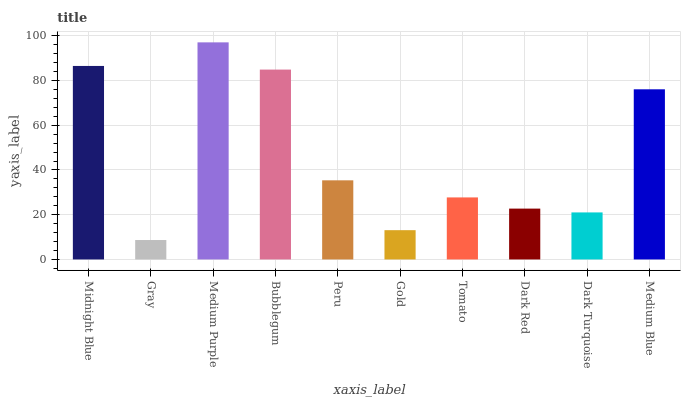Is Gray the minimum?
Answer yes or no. Yes. Is Medium Purple the maximum?
Answer yes or no. Yes. Is Medium Purple the minimum?
Answer yes or no. No. Is Gray the maximum?
Answer yes or no. No. Is Medium Purple greater than Gray?
Answer yes or no. Yes. Is Gray less than Medium Purple?
Answer yes or no. Yes. Is Gray greater than Medium Purple?
Answer yes or no. No. Is Medium Purple less than Gray?
Answer yes or no. No. Is Peru the high median?
Answer yes or no. Yes. Is Tomato the low median?
Answer yes or no. Yes. Is Tomato the high median?
Answer yes or no. No. Is Medium Purple the low median?
Answer yes or no. No. 